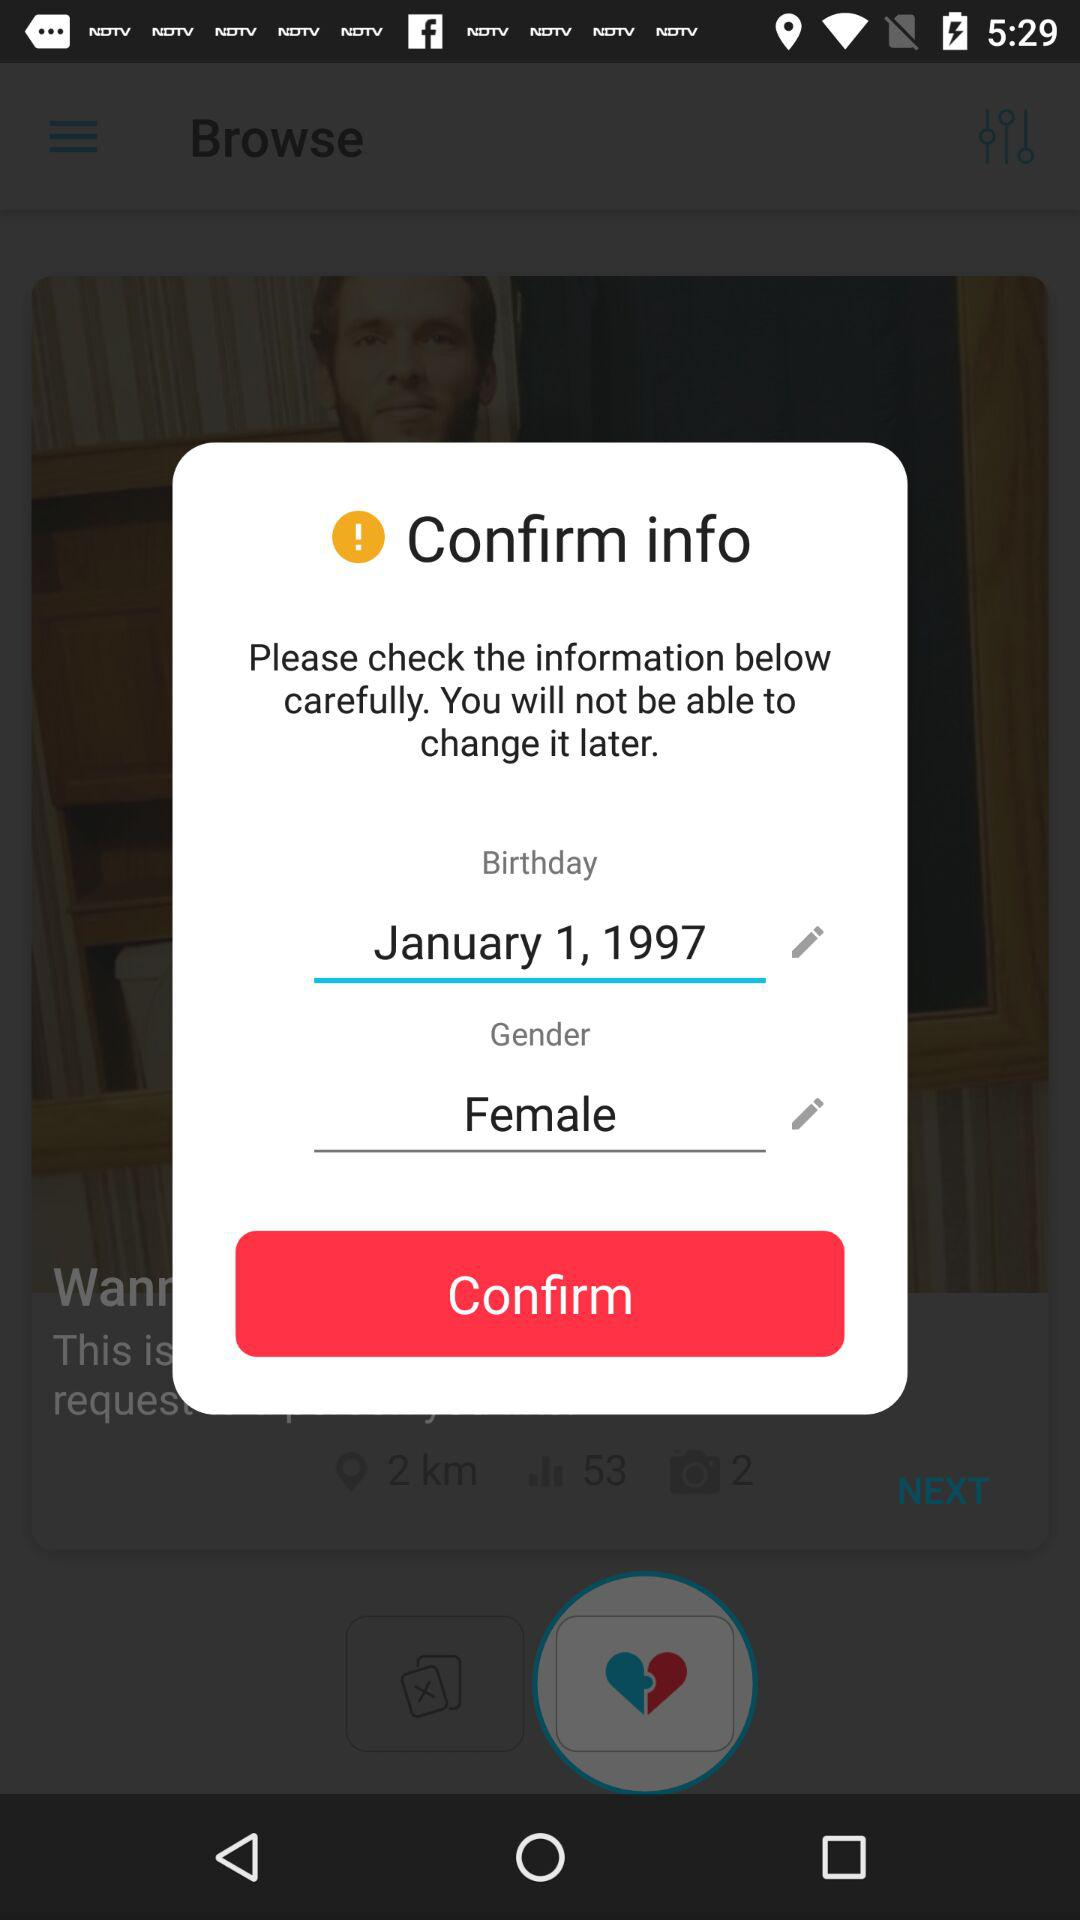What is the birthday date? The birthday date is January 1, 1997. 